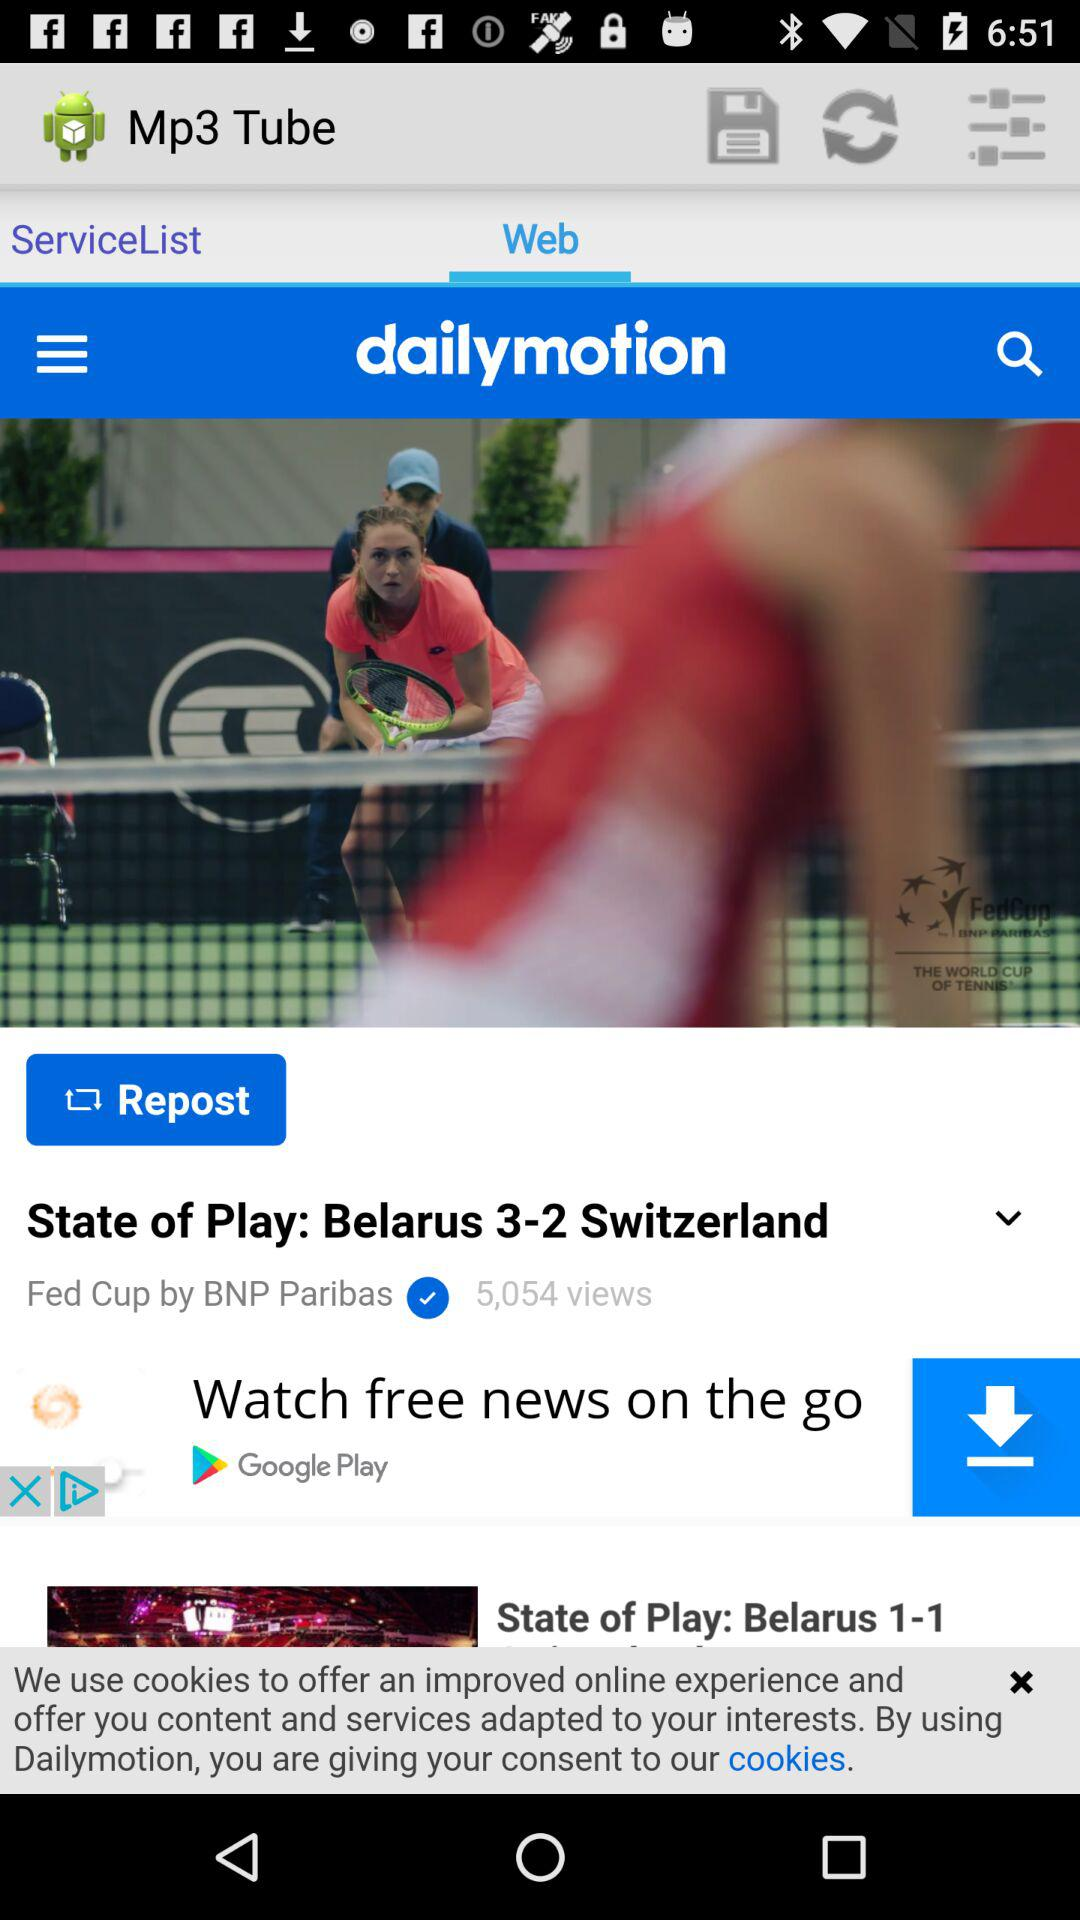What is the number of views of the news "State of Play: Belarus 3-2 Switzerland"? There are 5,054 views. 